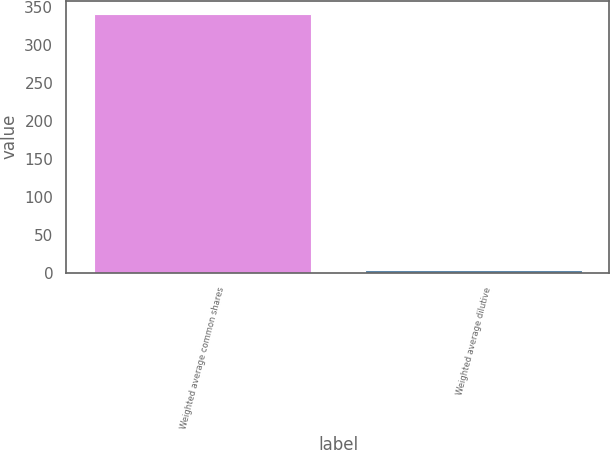Convert chart. <chart><loc_0><loc_0><loc_500><loc_500><bar_chart><fcel>Weighted average common shares<fcel>Weighted average dilutive<nl><fcel>341.33<fcel>4.4<nl></chart> 